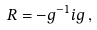<formula> <loc_0><loc_0><loc_500><loc_500>R = - g ^ { - 1 } i g \, ,</formula> 